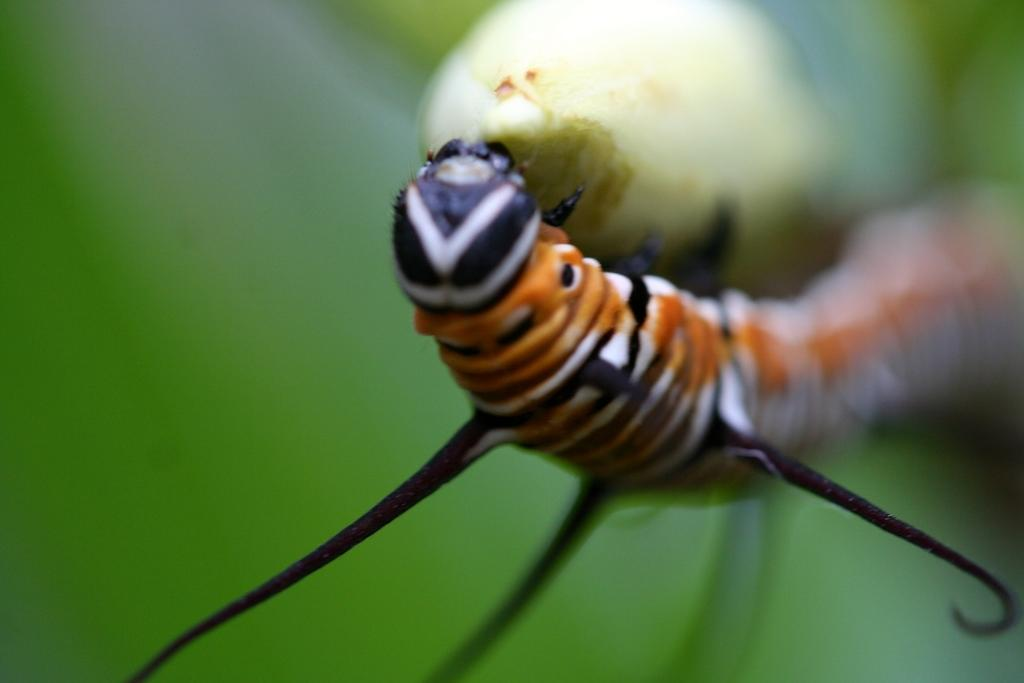What type of creature is in the image? There is an insect in the image. What colors can be seen on the insect? The insect has black, white, and orange colors. What is the insect resting on in the image? The insect is on a green object. What color is the background of the image? The background of the image is green. How many hairs can be seen on the insect in the image? There are no hairs visible on the insect in the image, as insects do not have hair. What order of insect is shown in the image? The specific order of the insect cannot be determined from the image alone. 